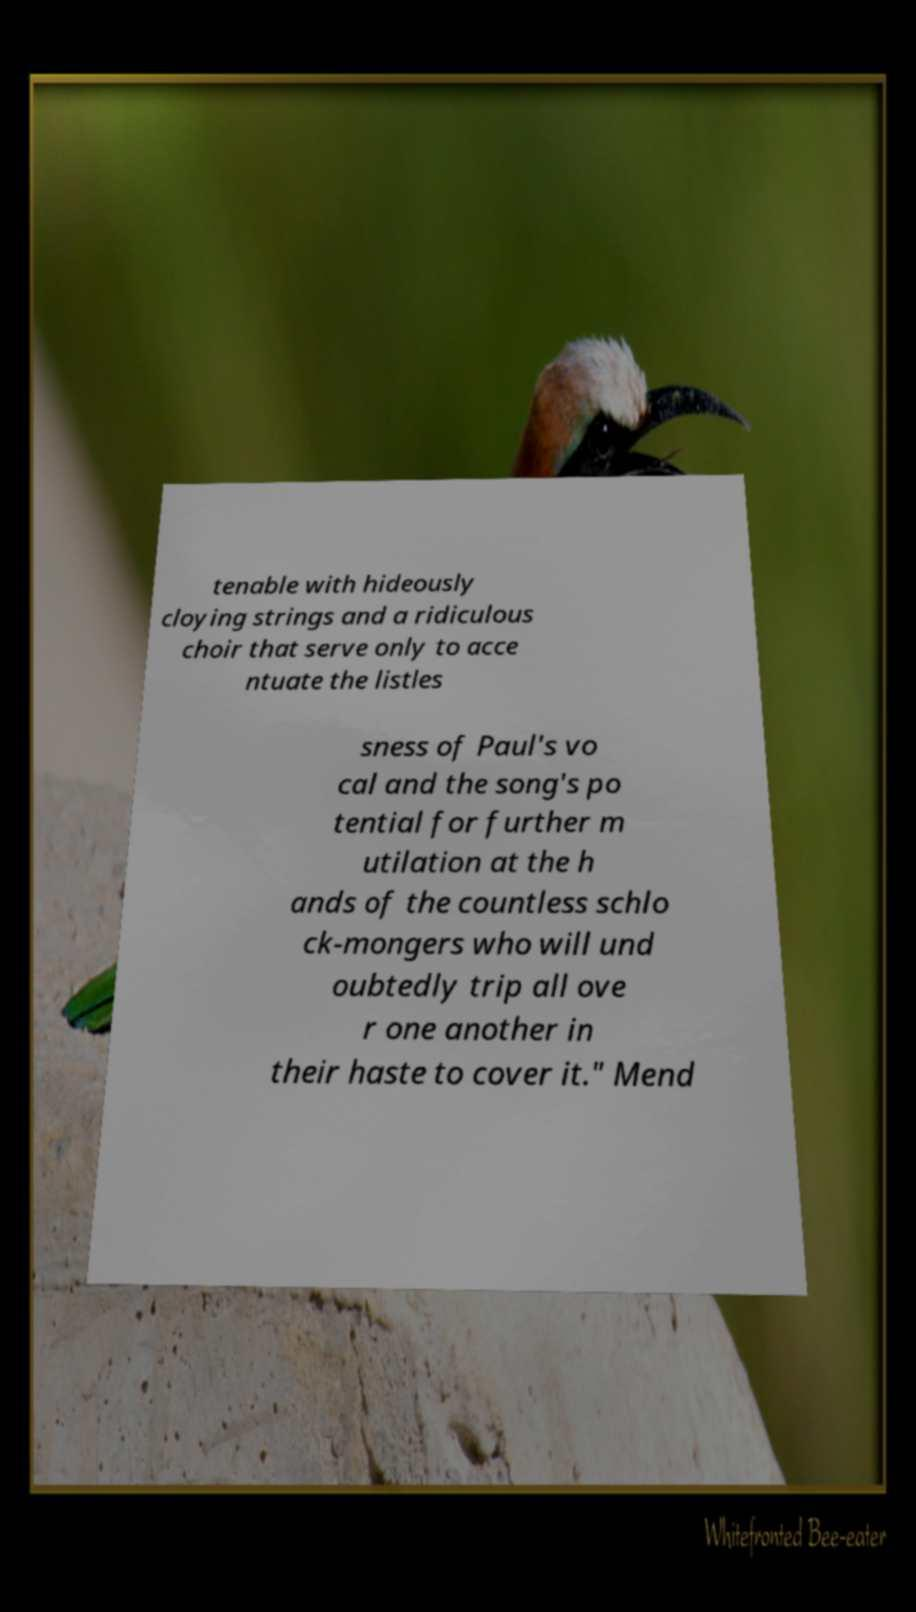For documentation purposes, I need the text within this image transcribed. Could you provide that? tenable with hideously cloying strings and a ridiculous choir that serve only to acce ntuate the listles sness of Paul's vo cal and the song's po tential for further m utilation at the h ands of the countless schlo ck-mongers who will und oubtedly trip all ove r one another in their haste to cover it." Mend 